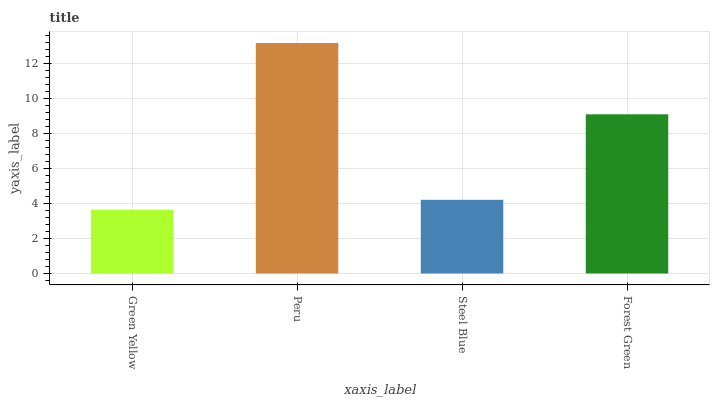Is Steel Blue the minimum?
Answer yes or no. No. Is Steel Blue the maximum?
Answer yes or no. No. Is Peru greater than Steel Blue?
Answer yes or no. Yes. Is Steel Blue less than Peru?
Answer yes or no. Yes. Is Steel Blue greater than Peru?
Answer yes or no. No. Is Peru less than Steel Blue?
Answer yes or no. No. Is Forest Green the high median?
Answer yes or no. Yes. Is Steel Blue the low median?
Answer yes or no. Yes. Is Green Yellow the high median?
Answer yes or no. No. Is Forest Green the low median?
Answer yes or no. No. 